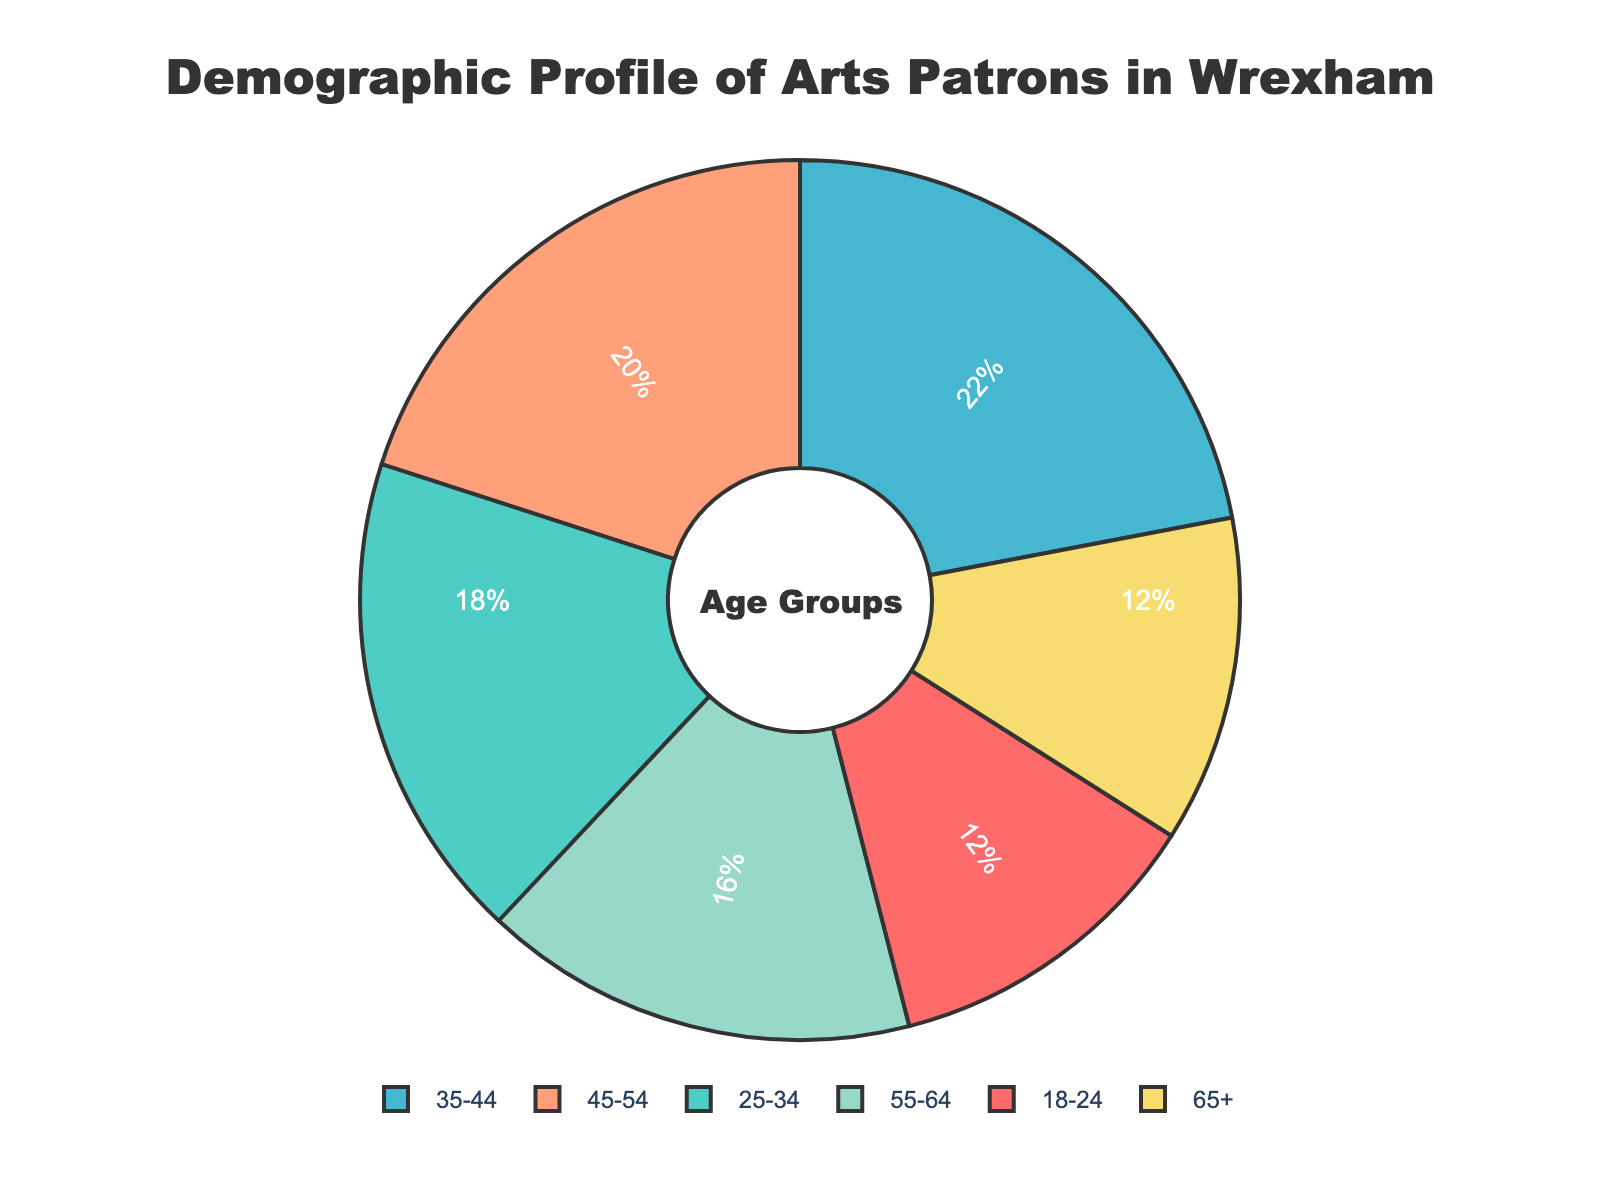What age group comprises the largest percentage of arts patrons in Wrexham? By looking at the pie chart, the largest segment represents the age group 35-44. The label shows that this group comprises 22% of arts patrons.
Answer: 35-44 Which two age groups are tied in their percentage of arts patrons and what is their percentage? Observing the pie chart, the age groups 18-24 and 65+ both have the same size segments. The labels confirm that both age groups comprise 12% of the arts patrons.
Answer: 18-24 and 65+, 12% How much higher is the percentage of arts patrons in the 35-44 age group compared to the 18-24 age group? Subtract the percentage of the 18-24 age group (12%) from the 35-44 age group (22%). The difference is \(22 - 12 = 10\%\).
Answer: 10% If you combine the percentages of patrons aged 25-34 and 45-54, what is the total? Add the percentages of the 25-34 age group (18%) and the 45-54 age group (20%). The total is \(18 + 20 = 38\%\).
Answer: 38% What is the combined percentage of arts patrons who are either younger than 25 or older than 64? Add the percentages of the 18-24 age group (12%) and the 65+ age group (12%). The combined percentage is \(12 + 12 = 24\%\).
Answer: 24% Is the percentage of patrons aged 55-64 greater or less than the percentage of those aged 25-34? Compare the percentages of the 55-64 age group (16%) with the 25-34 age group (18%). Since 16% is less than 18%, the percentage is less.
Answer: Less Which two age groups have the smallest representation among arts patrons, and how do their percentages compare? The two smallest segments in the pie chart represent age groups 18-24 and 65+, each with labels showing 12%. Their percentages are equal.
Answer: 18-24 and 65+, Equal What percentage of arts patrons falls within the prime working-age categories (25-54)? Sum the percentages of the 25-34 age group (18%), the 35-44 age group (22%), and the 45-54 age group (20%). The total is \(18 + 22 + 20 = 60\%\).
Answer: 60% Based on the visual size of the pie chart segments, which age group appears to be the second-most represented among arts patrons? The second-largest segment is slightly smaller than the largest. The pie chart indicates the segment for the 45-54 age group, with a percentage of 20%.
Answer: 45-54 